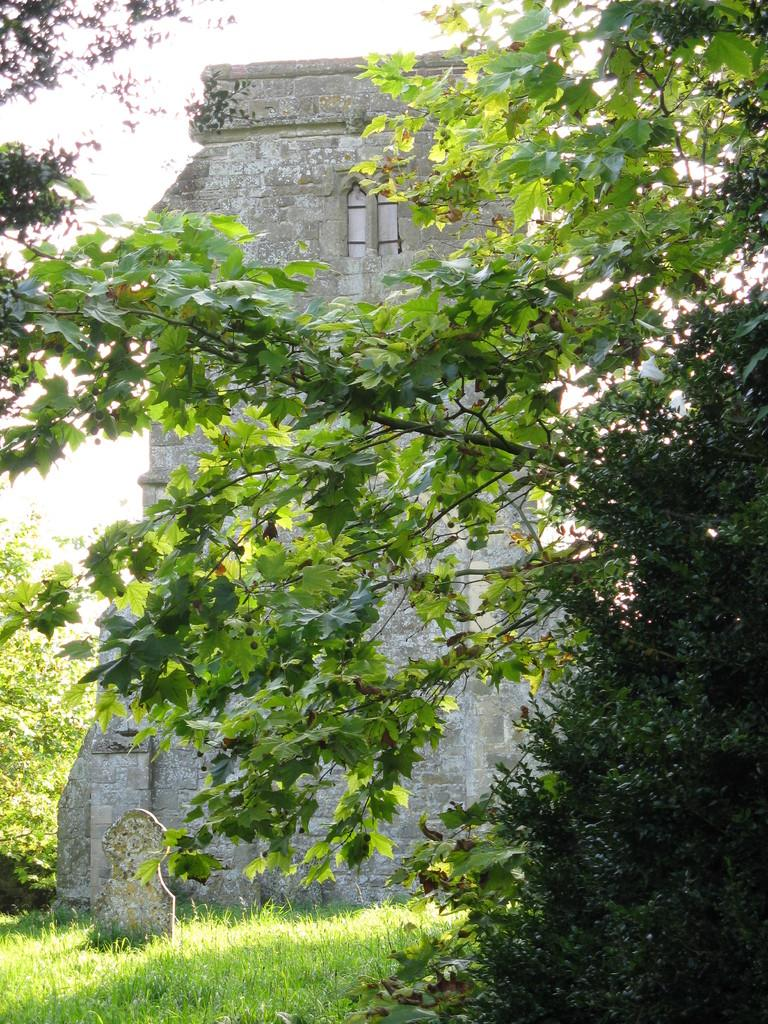What type of vegetation is in the middle of the image? There are trees in the middle of the image. What is located behind the trees in the image? There is a building behind the trees. What type of ground is visible at the bottom of the image? There is grass at the bottom of the image. What type of toothpaste is used to clean the leaves of the trees in the image? There is no toothpaste present in the image, and trees do not require cleaning with toothpaste. What is the acoustics like in the building behind the trees in the image? The acoustics of the building cannot be determined from the image alone, as it only shows the exterior of the building. 